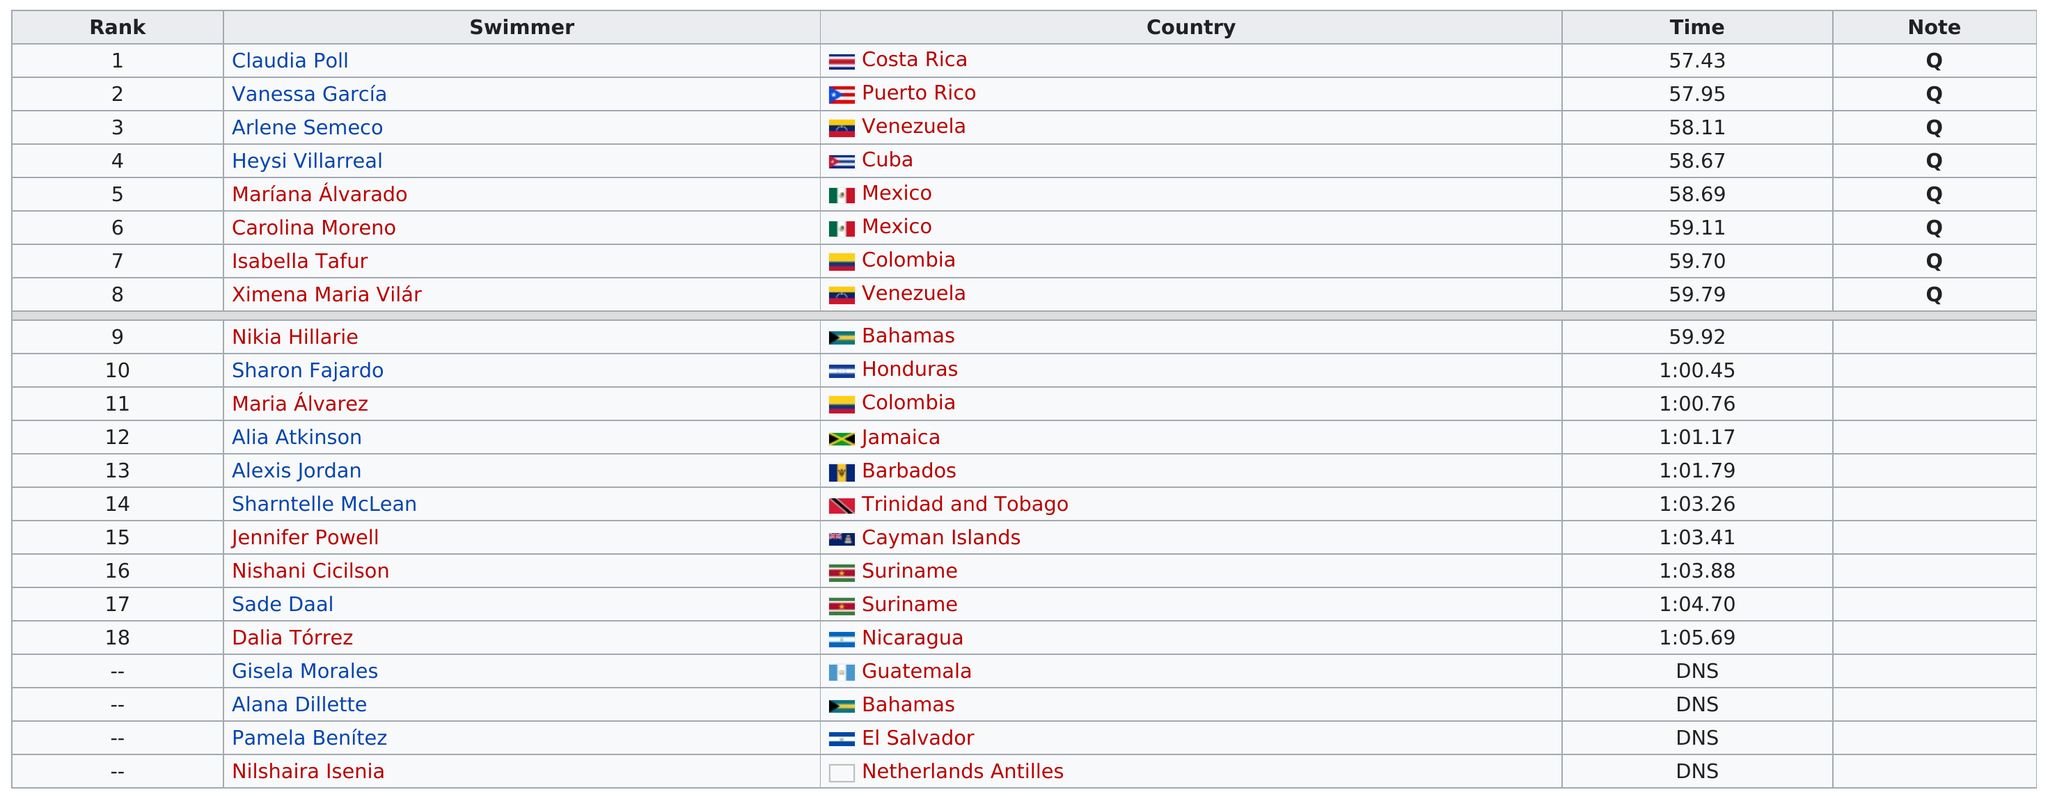Identify some key points in this picture. Claudia Roll's time was 57.43 seconds. Heysi Villarreal was the only Cuban to finish in the top eight, making him a standout competitor in the history of the event. Two competitors from Venezuela have qualified for the final round. Out of the total number of swimmers, 9 of them had a time of at least 1 minute. According to the ranking of Mexican swimmers, two of them have placed in the top 10. 